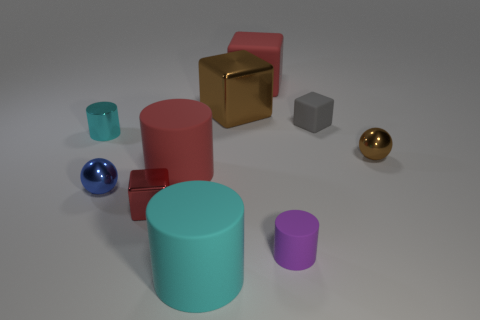Subtract all small shiny cylinders. How many cylinders are left? 3 Subtract all gray spheres. How many red cubes are left? 2 Subtract all brown balls. How many balls are left? 1 Subtract all spheres. How many objects are left? 8 Subtract 2 cylinders. How many cylinders are left? 2 Subtract all red matte cubes. Subtract all cylinders. How many objects are left? 5 Add 8 brown metallic balls. How many brown metallic balls are left? 9 Add 1 large red metallic blocks. How many large red metallic blocks exist? 1 Subtract 1 red blocks. How many objects are left? 9 Subtract all yellow cylinders. Subtract all gray cubes. How many cylinders are left? 4 